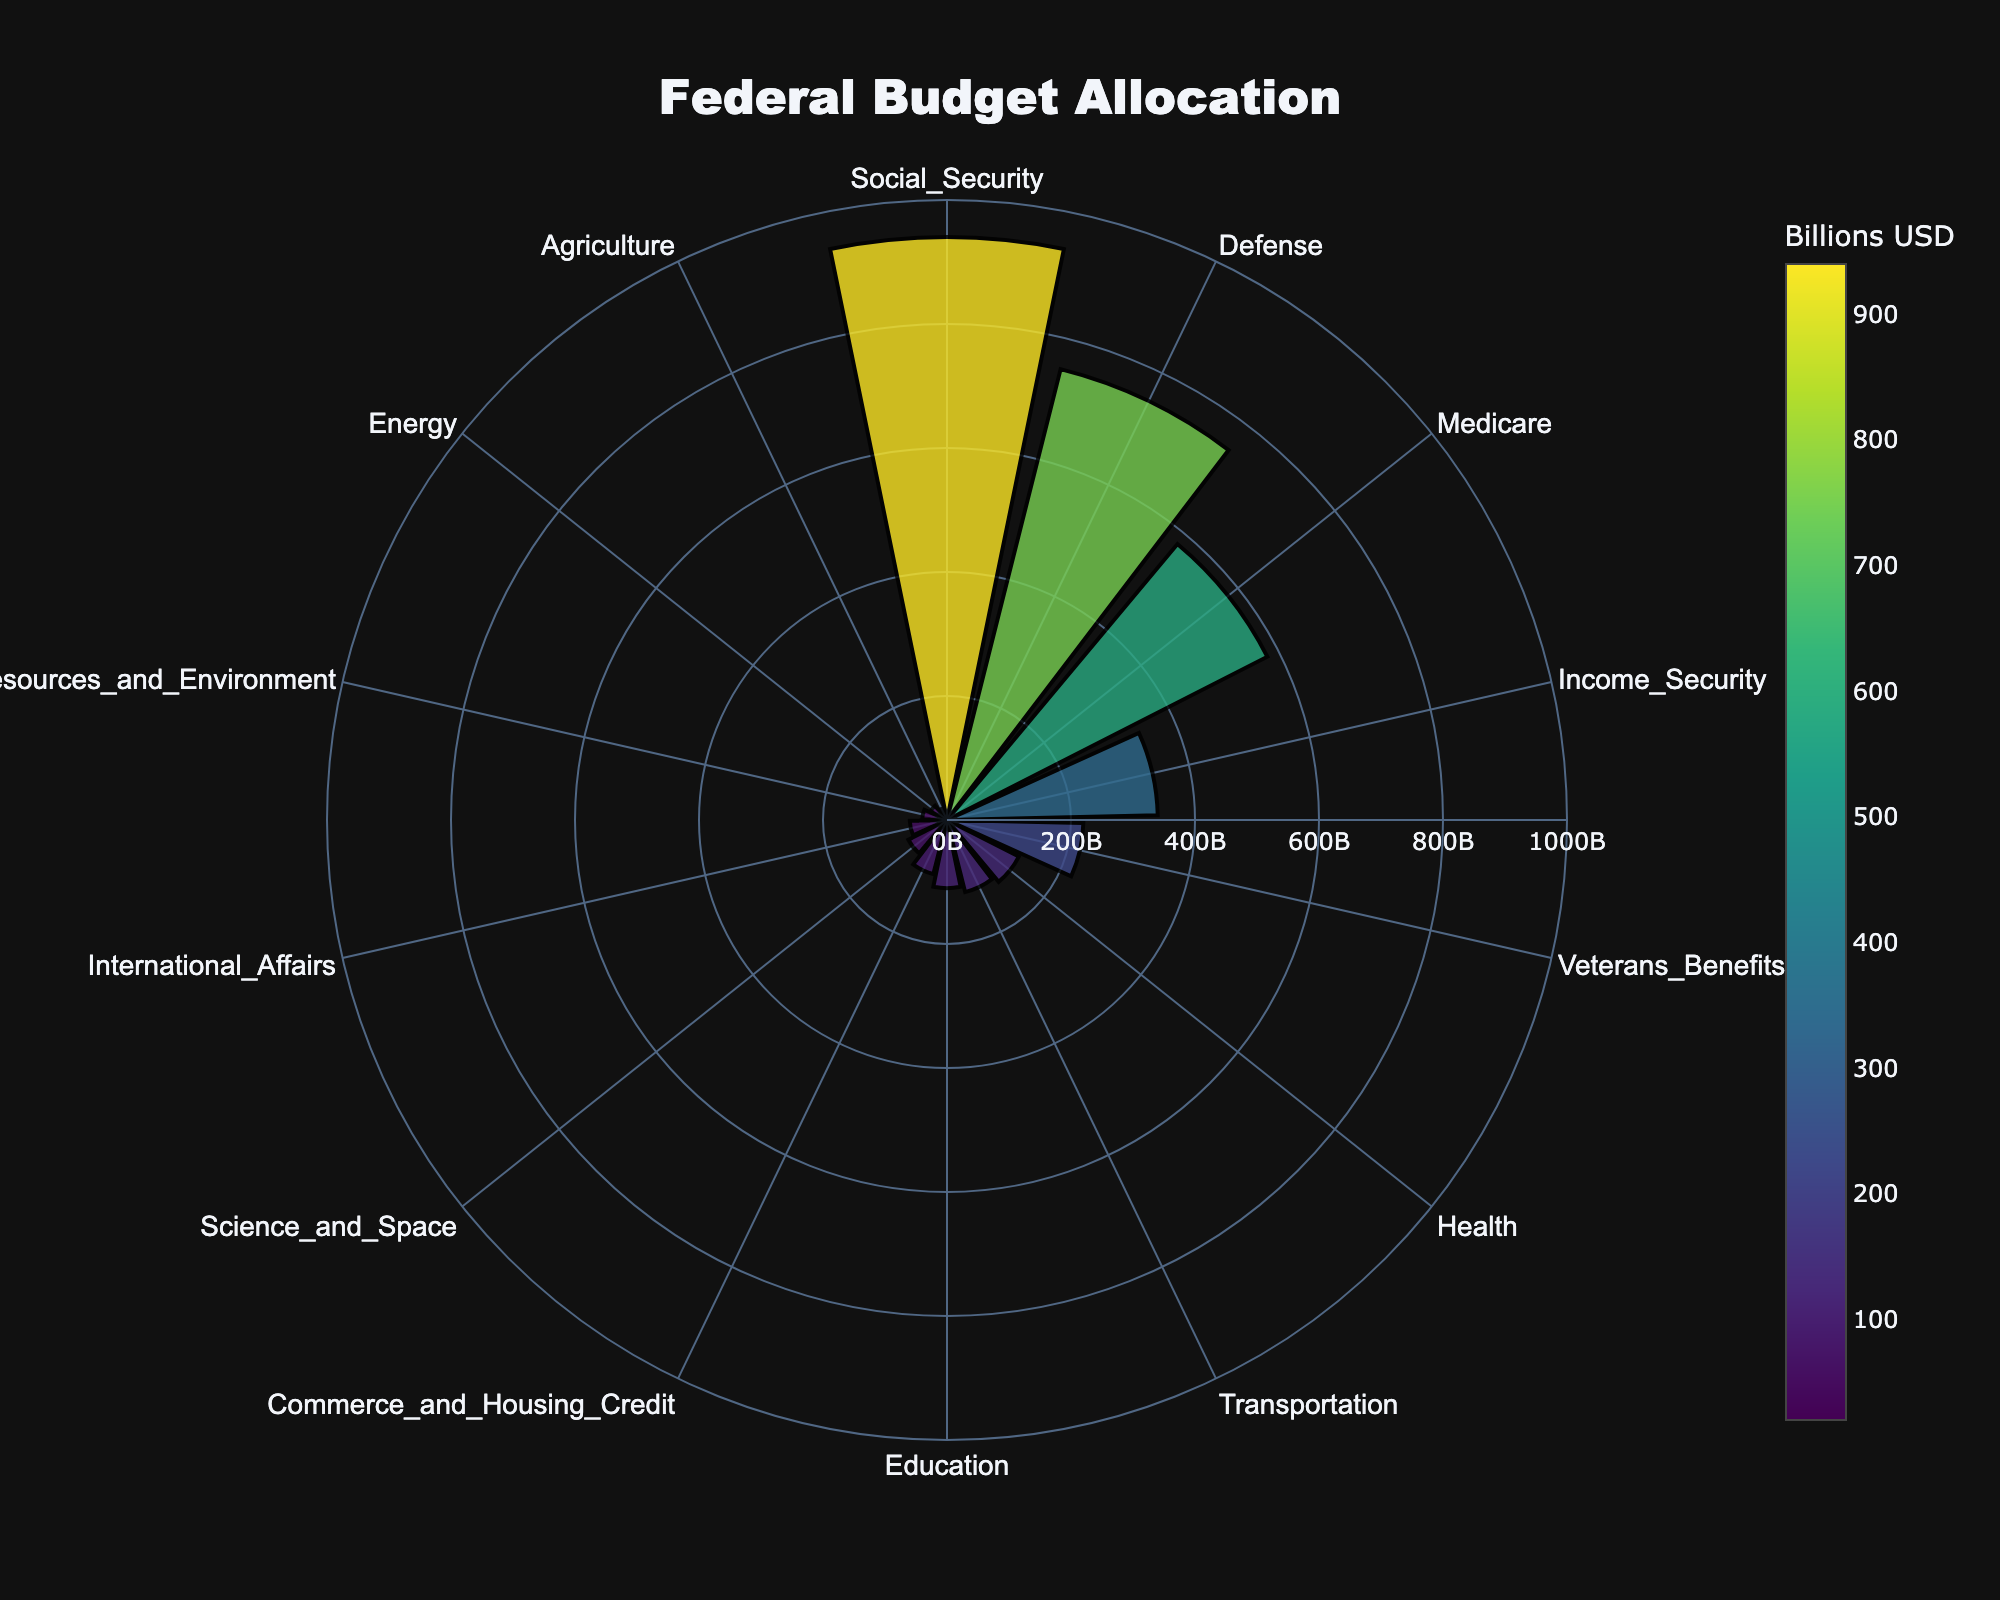Which category receives the highest allocation in the federal budget? The polar area chart shows different sectors and their respective allocations as radial lengths. The longest radial length represents the highest allocation. From the chart, Social Security has the longest radius.
Answer: Social Security What is the total allocation for Defense, Education, and Health sectors combined? To find the total allocation for these sectors, sum up their respective values: Defense (750), Education (110), and Health (130). So, the total is 750 + 110 + 130 = 990.
Answer: 990 Billion USD How does the allocation for Veterans Benefits compare to that of Transportation? The chart displays the radial lengths for different sectors. The radial length for Veterans Benefits is longer than Transportation, indicating a higher allocation. Specifically, Veterans Benefits is 220, and Transportation is 120.
Answer: Veterans Benefits is higher Which category has the lowest allocation? The category with the shortest radius in the polar area chart represents the lowest allocation. This is the Agriculture sector.
Answer: Agriculture What is the range of allocations across the sectors? The range is found by subtracting the smallest allocation from the largest allocation. The largest allocation is for Social Security (940) and the smallest is for Agriculture (20). So, the range is 940 - 20 = 920.
Answer: 920 Billion USD What is the average allocation among all the listed sectors? To find the average, sum up all the allocations and divide by the number of sectors. The total allocation is 750+110+130+940+580+340+220+120+90+60+40+70+30+20 = 3500. There are 14 sectors. The average is 3500 / 14 ≈ 250.
Answer: Approximately 250 Billion USD Which two sectors combined would have an allocation close to that of Medicare? Medicare has an allocation of 580. Comparing the sectors, Defense (750) and Commerce and Housing Credit (90) together make 750 + 90 = 840, which is close. This approach involves trying out combinations that add up to or near Medicare's value. For simplicity, we use direct observation to find two values summing closely to 580. After reviewing, Defense and Natural Resources and Environment add up to 750 + 40 = 790, which is closest among potential pairs.
Answer: Defense and Commerce and Housing Credit Which sectors have an allocation greater than the average allocation? The average allocation is approximately 250 Billion USD. Sectors with an allocation greater than 250 are Defense, Social Security, Medicare, Income Security, and Veterans Benefits.
Answer: Defense, Social Security, Medicare, Income Security, Veterans Benefits Does the allocation for Science and Space exceed that for International Affairs? The chart indicates the radial lengths for each sector. Science and Space has a longer radius than International Affairs. Specifically, Science and Space is allocated 70, while International Affairs is allocated 60.
Answer: Yes If 10% of the Defense budget were reallocated to Education, what would be the new allocations for Defense and Education? 10% of the Defense budget (750) is 75. Subtract 75 from Defense and add to Education: new Defense budget = 750 - 75 = 675, new Education budget = 110 + 75 = 185.
Answer: Defense: 675 Billion USD, Education: 185 Billion USD 